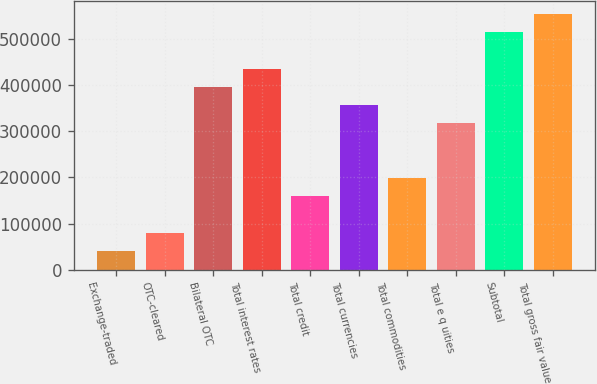<chart> <loc_0><loc_0><loc_500><loc_500><bar_chart><fcel>Exchange-traded<fcel>OTC-cleared<fcel>Bilateral OTC<fcel>Total interest rates<fcel>Total credit<fcel>Total currencies<fcel>Total commodities<fcel>Total e q uities<fcel>Subtotal<fcel>Total gross fair value<nl><fcel>40789.9<fcel>80251.8<fcel>395947<fcel>435409<fcel>159176<fcel>356485<fcel>198638<fcel>317023<fcel>514333<fcel>553795<nl></chart> 